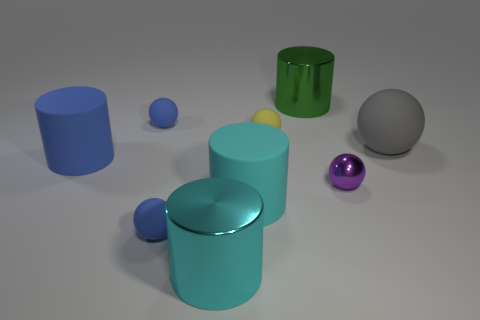How many other things are there of the same material as the small yellow thing?
Your response must be concise. 5. Does the small object that is behind the yellow matte thing have the same material as the small thing right of the large green metal cylinder?
Ensure brevity in your answer.  No. There is a large blue thing that is the same material as the small yellow ball; what is its shape?
Offer a terse response. Cylinder. Are there any other things of the same color as the shiny sphere?
Your answer should be very brief. No. How many small brown metallic blocks are there?
Provide a short and direct response. 0. What shape is the large rubber object that is both to the left of the purple thing and behind the large cyan rubber cylinder?
Your answer should be very brief. Cylinder. What shape is the big rubber thing that is in front of the matte cylinder behind the small purple ball to the right of the yellow rubber ball?
Give a very brief answer. Cylinder. There is a small sphere that is both in front of the large blue rubber cylinder and on the right side of the cyan matte cylinder; what material is it?
Give a very brief answer. Metal. What number of green shiny cylinders are the same size as the cyan metallic object?
Provide a succinct answer. 1. How many shiny things are large green objects or big blue objects?
Provide a short and direct response. 1. 